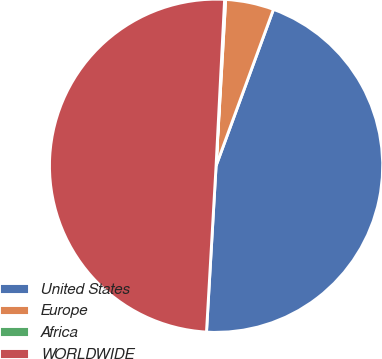Convert chart to OTSL. <chart><loc_0><loc_0><loc_500><loc_500><pie_chart><fcel>United States<fcel>Europe<fcel>Africa<fcel>WORLDWIDE<nl><fcel>45.32%<fcel>4.68%<fcel>0.1%<fcel>49.9%<nl></chart> 